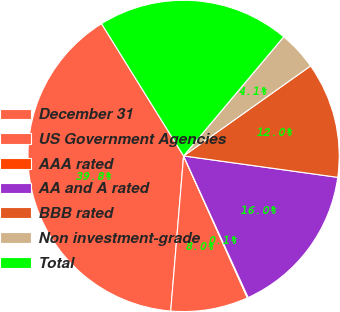<chart> <loc_0><loc_0><loc_500><loc_500><pie_chart><fcel>December 31<fcel>US Government Agencies<fcel>AAA rated<fcel>AA and A rated<fcel>BBB rated<fcel>Non investment-grade<fcel>Total<nl><fcel>39.84%<fcel>8.04%<fcel>0.09%<fcel>15.99%<fcel>12.01%<fcel>4.06%<fcel>19.96%<nl></chart> 